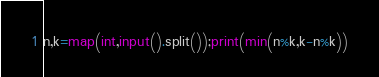Convert code to text. <code><loc_0><loc_0><loc_500><loc_500><_Python_>n,k=map(int,input().split());print(min(n%k,k-n%k))</code> 